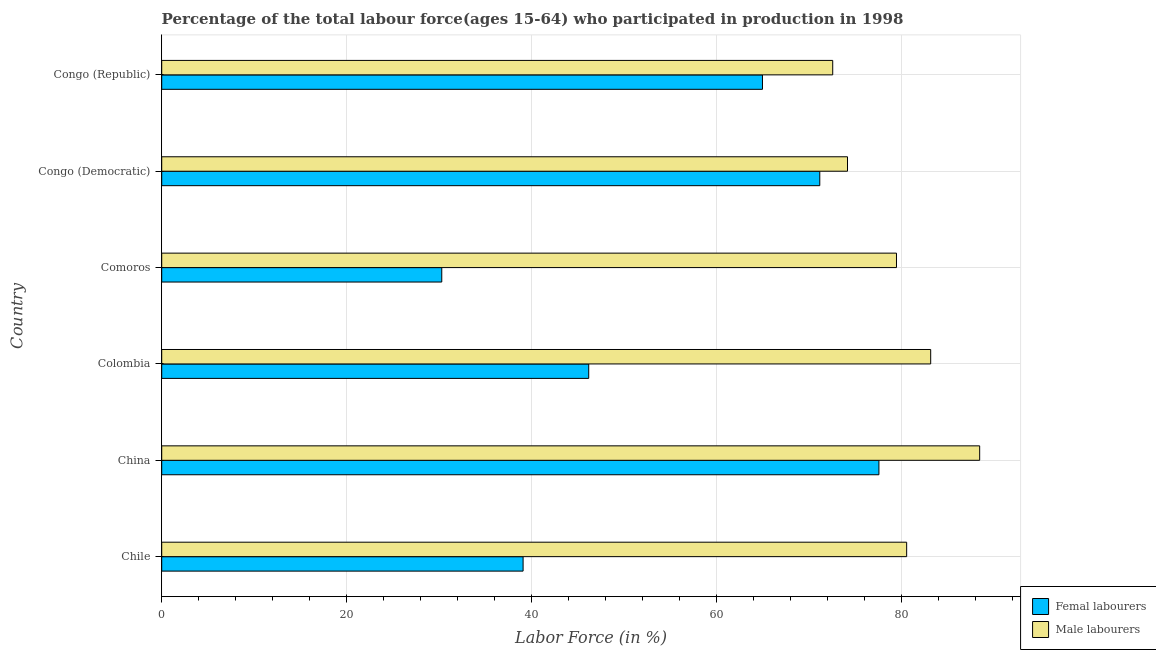How many different coloured bars are there?
Make the answer very short. 2. How many groups of bars are there?
Give a very brief answer. 6. Are the number of bars on each tick of the Y-axis equal?
Make the answer very short. Yes. How many bars are there on the 1st tick from the top?
Make the answer very short. 2. How many bars are there on the 6th tick from the bottom?
Your answer should be compact. 2. What is the percentage of male labour force in Chile?
Provide a succinct answer. 80.6. Across all countries, what is the maximum percentage of male labour force?
Offer a terse response. 88.5. Across all countries, what is the minimum percentage of male labour force?
Provide a short and direct response. 72.6. In which country was the percentage of female labor force minimum?
Offer a terse response. Comoros. What is the total percentage of female labor force in the graph?
Provide a succinct answer. 329.4. What is the difference between the percentage of male labour force in Comoros and that in Congo (Republic)?
Make the answer very short. 6.9. What is the average percentage of female labor force per country?
Offer a very short reply. 54.9. What is the difference between the percentage of female labor force and percentage of male labour force in Colombia?
Your answer should be compact. -37. In how many countries, is the percentage of female labor force greater than 52 %?
Your answer should be compact. 3. What is the ratio of the percentage of female labor force in Comoros to that in Congo (Republic)?
Offer a very short reply. 0.47. What is the difference between the highest and the second highest percentage of male labour force?
Provide a succinct answer. 5.3. What is the difference between the highest and the lowest percentage of male labour force?
Offer a terse response. 15.9. What does the 1st bar from the top in Congo (Republic) represents?
Ensure brevity in your answer.  Male labourers. What does the 1st bar from the bottom in Chile represents?
Make the answer very short. Femal labourers. How many bars are there?
Offer a terse response. 12. What is the difference between two consecutive major ticks on the X-axis?
Keep it short and to the point. 20. Are the values on the major ticks of X-axis written in scientific E-notation?
Offer a terse response. No. Where does the legend appear in the graph?
Make the answer very short. Bottom right. How are the legend labels stacked?
Provide a short and direct response. Vertical. What is the title of the graph?
Provide a short and direct response. Percentage of the total labour force(ages 15-64) who participated in production in 1998. Does "Urban Population" appear as one of the legend labels in the graph?
Offer a terse response. No. What is the label or title of the X-axis?
Keep it short and to the point. Labor Force (in %). What is the Labor Force (in %) of Femal labourers in Chile?
Give a very brief answer. 39.1. What is the Labor Force (in %) in Male labourers in Chile?
Keep it short and to the point. 80.6. What is the Labor Force (in %) of Femal labourers in China?
Your answer should be compact. 77.6. What is the Labor Force (in %) in Male labourers in China?
Give a very brief answer. 88.5. What is the Labor Force (in %) in Femal labourers in Colombia?
Your answer should be very brief. 46.2. What is the Labor Force (in %) of Male labourers in Colombia?
Offer a very short reply. 83.2. What is the Labor Force (in %) in Femal labourers in Comoros?
Ensure brevity in your answer.  30.3. What is the Labor Force (in %) of Male labourers in Comoros?
Provide a short and direct response. 79.5. What is the Labor Force (in %) of Femal labourers in Congo (Democratic)?
Keep it short and to the point. 71.2. What is the Labor Force (in %) of Male labourers in Congo (Democratic)?
Give a very brief answer. 74.2. What is the Labor Force (in %) in Femal labourers in Congo (Republic)?
Your response must be concise. 65. What is the Labor Force (in %) in Male labourers in Congo (Republic)?
Give a very brief answer. 72.6. Across all countries, what is the maximum Labor Force (in %) of Femal labourers?
Give a very brief answer. 77.6. Across all countries, what is the maximum Labor Force (in %) of Male labourers?
Provide a short and direct response. 88.5. Across all countries, what is the minimum Labor Force (in %) in Femal labourers?
Give a very brief answer. 30.3. Across all countries, what is the minimum Labor Force (in %) in Male labourers?
Your answer should be compact. 72.6. What is the total Labor Force (in %) of Femal labourers in the graph?
Your answer should be very brief. 329.4. What is the total Labor Force (in %) in Male labourers in the graph?
Your answer should be compact. 478.6. What is the difference between the Labor Force (in %) of Femal labourers in Chile and that in China?
Your answer should be compact. -38.5. What is the difference between the Labor Force (in %) in Femal labourers in Chile and that in Colombia?
Your answer should be very brief. -7.1. What is the difference between the Labor Force (in %) of Male labourers in Chile and that in Colombia?
Your answer should be compact. -2.6. What is the difference between the Labor Force (in %) of Male labourers in Chile and that in Comoros?
Make the answer very short. 1.1. What is the difference between the Labor Force (in %) in Femal labourers in Chile and that in Congo (Democratic)?
Provide a short and direct response. -32.1. What is the difference between the Labor Force (in %) of Male labourers in Chile and that in Congo (Democratic)?
Provide a succinct answer. 6.4. What is the difference between the Labor Force (in %) of Femal labourers in Chile and that in Congo (Republic)?
Ensure brevity in your answer.  -25.9. What is the difference between the Labor Force (in %) in Femal labourers in China and that in Colombia?
Provide a succinct answer. 31.4. What is the difference between the Labor Force (in %) in Femal labourers in China and that in Comoros?
Offer a terse response. 47.3. What is the difference between the Labor Force (in %) in Male labourers in China and that in Congo (Republic)?
Offer a very short reply. 15.9. What is the difference between the Labor Force (in %) in Male labourers in Colombia and that in Comoros?
Offer a terse response. 3.7. What is the difference between the Labor Force (in %) in Femal labourers in Colombia and that in Congo (Democratic)?
Your answer should be very brief. -25. What is the difference between the Labor Force (in %) in Femal labourers in Colombia and that in Congo (Republic)?
Your answer should be compact. -18.8. What is the difference between the Labor Force (in %) in Femal labourers in Comoros and that in Congo (Democratic)?
Offer a very short reply. -40.9. What is the difference between the Labor Force (in %) in Male labourers in Comoros and that in Congo (Democratic)?
Your answer should be compact. 5.3. What is the difference between the Labor Force (in %) in Femal labourers in Comoros and that in Congo (Republic)?
Keep it short and to the point. -34.7. What is the difference between the Labor Force (in %) in Male labourers in Comoros and that in Congo (Republic)?
Offer a very short reply. 6.9. What is the difference between the Labor Force (in %) in Femal labourers in Chile and the Labor Force (in %) in Male labourers in China?
Provide a succinct answer. -49.4. What is the difference between the Labor Force (in %) of Femal labourers in Chile and the Labor Force (in %) of Male labourers in Colombia?
Keep it short and to the point. -44.1. What is the difference between the Labor Force (in %) of Femal labourers in Chile and the Labor Force (in %) of Male labourers in Comoros?
Keep it short and to the point. -40.4. What is the difference between the Labor Force (in %) of Femal labourers in Chile and the Labor Force (in %) of Male labourers in Congo (Democratic)?
Provide a succinct answer. -35.1. What is the difference between the Labor Force (in %) in Femal labourers in Chile and the Labor Force (in %) in Male labourers in Congo (Republic)?
Offer a very short reply. -33.5. What is the difference between the Labor Force (in %) of Femal labourers in China and the Labor Force (in %) of Male labourers in Colombia?
Make the answer very short. -5.6. What is the difference between the Labor Force (in %) in Femal labourers in China and the Labor Force (in %) in Male labourers in Comoros?
Your answer should be very brief. -1.9. What is the difference between the Labor Force (in %) of Femal labourers in China and the Labor Force (in %) of Male labourers in Congo (Republic)?
Your response must be concise. 5. What is the difference between the Labor Force (in %) in Femal labourers in Colombia and the Labor Force (in %) in Male labourers in Comoros?
Offer a very short reply. -33.3. What is the difference between the Labor Force (in %) in Femal labourers in Colombia and the Labor Force (in %) in Male labourers in Congo (Republic)?
Make the answer very short. -26.4. What is the difference between the Labor Force (in %) of Femal labourers in Comoros and the Labor Force (in %) of Male labourers in Congo (Democratic)?
Your response must be concise. -43.9. What is the difference between the Labor Force (in %) of Femal labourers in Comoros and the Labor Force (in %) of Male labourers in Congo (Republic)?
Give a very brief answer. -42.3. What is the difference between the Labor Force (in %) of Femal labourers in Congo (Democratic) and the Labor Force (in %) of Male labourers in Congo (Republic)?
Your response must be concise. -1.4. What is the average Labor Force (in %) in Femal labourers per country?
Provide a short and direct response. 54.9. What is the average Labor Force (in %) in Male labourers per country?
Keep it short and to the point. 79.77. What is the difference between the Labor Force (in %) in Femal labourers and Labor Force (in %) in Male labourers in Chile?
Provide a short and direct response. -41.5. What is the difference between the Labor Force (in %) in Femal labourers and Labor Force (in %) in Male labourers in Colombia?
Offer a terse response. -37. What is the difference between the Labor Force (in %) in Femal labourers and Labor Force (in %) in Male labourers in Comoros?
Ensure brevity in your answer.  -49.2. What is the difference between the Labor Force (in %) of Femal labourers and Labor Force (in %) of Male labourers in Congo (Republic)?
Your answer should be very brief. -7.6. What is the ratio of the Labor Force (in %) of Femal labourers in Chile to that in China?
Provide a short and direct response. 0.5. What is the ratio of the Labor Force (in %) of Male labourers in Chile to that in China?
Make the answer very short. 0.91. What is the ratio of the Labor Force (in %) of Femal labourers in Chile to that in Colombia?
Offer a very short reply. 0.85. What is the ratio of the Labor Force (in %) in Male labourers in Chile to that in Colombia?
Provide a short and direct response. 0.97. What is the ratio of the Labor Force (in %) in Femal labourers in Chile to that in Comoros?
Your response must be concise. 1.29. What is the ratio of the Labor Force (in %) in Male labourers in Chile to that in Comoros?
Ensure brevity in your answer.  1.01. What is the ratio of the Labor Force (in %) of Femal labourers in Chile to that in Congo (Democratic)?
Give a very brief answer. 0.55. What is the ratio of the Labor Force (in %) of Male labourers in Chile to that in Congo (Democratic)?
Your response must be concise. 1.09. What is the ratio of the Labor Force (in %) of Femal labourers in Chile to that in Congo (Republic)?
Keep it short and to the point. 0.6. What is the ratio of the Labor Force (in %) of Male labourers in Chile to that in Congo (Republic)?
Offer a terse response. 1.11. What is the ratio of the Labor Force (in %) in Femal labourers in China to that in Colombia?
Offer a terse response. 1.68. What is the ratio of the Labor Force (in %) in Male labourers in China to that in Colombia?
Make the answer very short. 1.06. What is the ratio of the Labor Force (in %) in Femal labourers in China to that in Comoros?
Offer a terse response. 2.56. What is the ratio of the Labor Force (in %) in Male labourers in China to that in Comoros?
Provide a succinct answer. 1.11. What is the ratio of the Labor Force (in %) of Femal labourers in China to that in Congo (Democratic)?
Your response must be concise. 1.09. What is the ratio of the Labor Force (in %) of Male labourers in China to that in Congo (Democratic)?
Ensure brevity in your answer.  1.19. What is the ratio of the Labor Force (in %) of Femal labourers in China to that in Congo (Republic)?
Make the answer very short. 1.19. What is the ratio of the Labor Force (in %) of Male labourers in China to that in Congo (Republic)?
Your answer should be compact. 1.22. What is the ratio of the Labor Force (in %) of Femal labourers in Colombia to that in Comoros?
Provide a short and direct response. 1.52. What is the ratio of the Labor Force (in %) in Male labourers in Colombia to that in Comoros?
Offer a terse response. 1.05. What is the ratio of the Labor Force (in %) in Femal labourers in Colombia to that in Congo (Democratic)?
Offer a very short reply. 0.65. What is the ratio of the Labor Force (in %) of Male labourers in Colombia to that in Congo (Democratic)?
Keep it short and to the point. 1.12. What is the ratio of the Labor Force (in %) in Femal labourers in Colombia to that in Congo (Republic)?
Make the answer very short. 0.71. What is the ratio of the Labor Force (in %) of Male labourers in Colombia to that in Congo (Republic)?
Your answer should be compact. 1.15. What is the ratio of the Labor Force (in %) of Femal labourers in Comoros to that in Congo (Democratic)?
Provide a short and direct response. 0.43. What is the ratio of the Labor Force (in %) of Male labourers in Comoros to that in Congo (Democratic)?
Make the answer very short. 1.07. What is the ratio of the Labor Force (in %) in Femal labourers in Comoros to that in Congo (Republic)?
Provide a succinct answer. 0.47. What is the ratio of the Labor Force (in %) in Male labourers in Comoros to that in Congo (Republic)?
Offer a very short reply. 1.09. What is the ratio of the Labor Force (in %) of Femal labourers in Congo (Democratic) to that in Congo (Republic)?
Give a very brief answer. 1.1. What is the ratio of the Labor Force (in %) in Male labourers in Congo (Democratic) to that in Congo (Republic)?
Your answer should be very brief. 1.02. What is the difference between the highest and the second highest Labor Force (in %) in Femal labourers?
Provide a short and direct response. 6.4. What is the difference between the highest and the lowest Labor Force (in %) of Femal labourers?
Provide a succinct answer. 47.3. What is the difference between the highest and the lowest Labor Force (in %) of Male labourers?
Give a very brief answer. 15.9. 